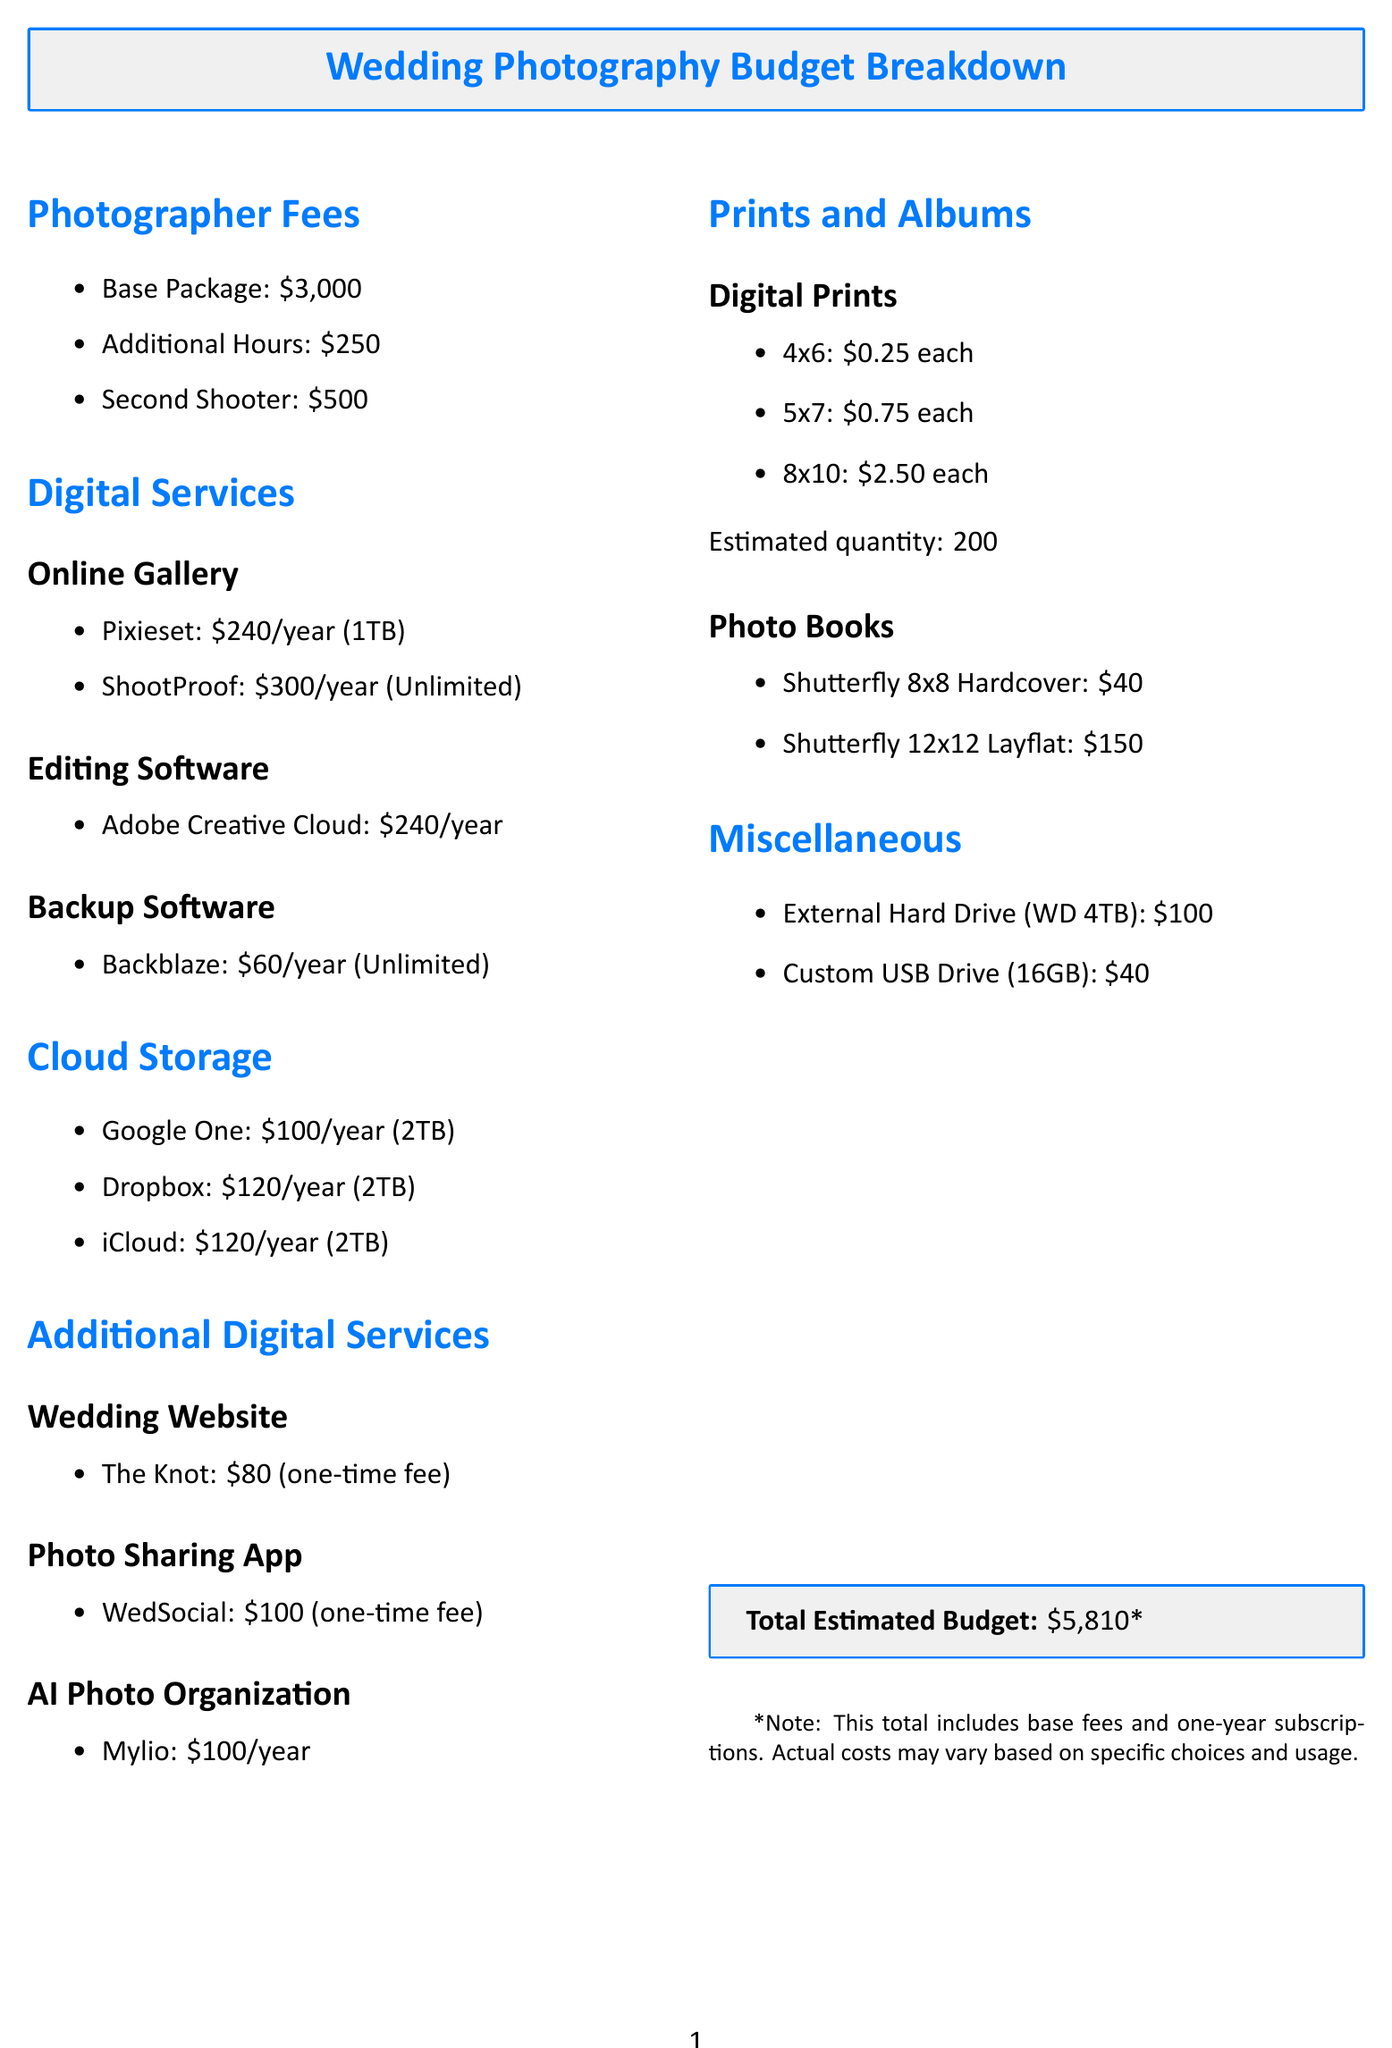what is the base package fee for the photographer? The base package fee for the photographer is specified in the document as $3,000.
Answer: $3,000 how much does Backblaze cost per year? Backblaze costs $60 per year as indicated in the digital services section.
Answer: $60 what is the annual subscription for Adobe Creative Cloud? The annual subscription for Adobe Creative Cloud is listed as $240 in the document.
Answer: $240 how many TB of storage does ShootProof provide? ShootProof provides unlimited storage according to the digital services section.
Answer: Unlimited what is the total estimated budget for wedding photography? The total estimated budget is presented at the end of the document, calculated from all the costs listed.
Answer: $5,810 how much would it cost to print 200 digital prints of 4x6 size? The cost to print 200 digital prints of size 4x6 is calculated as $0.25 each, so the total would be $0.25 times 200.
Answer: $50 which service offers real-time photo uploads? The service that offers real-time photo uploads is identified as WedSocial in the additional digital services section.
Answer: WedSocial which cloud storage option has the highest annual subscription? The cloud storage option with the highest annual subscription is ShootProof at $300.
Answer: ShootProof 